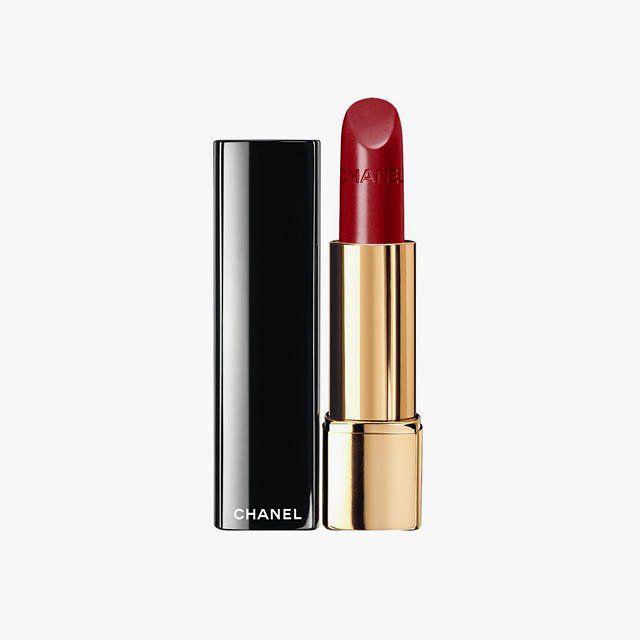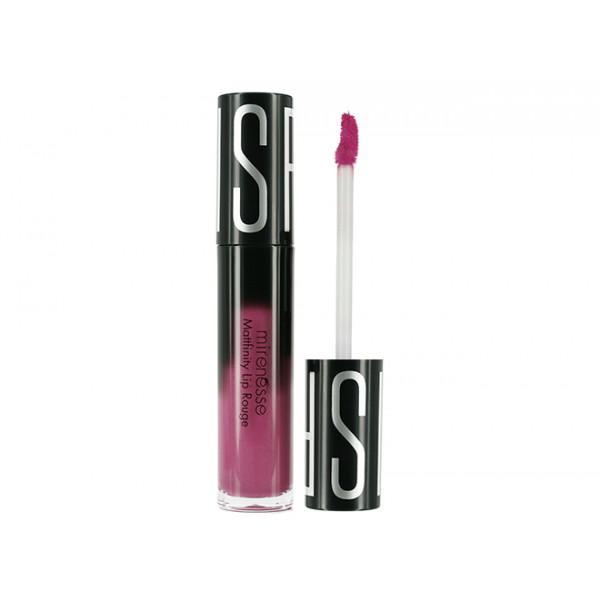The first image is the image on the left, the second image is the image on the right. For the images displayed, is the sentence "One open tube of lipstick is black with a visible logo somewhere on the tube, and the black cap laying sideways beside it." factually correct? Answer yes or no. No. 